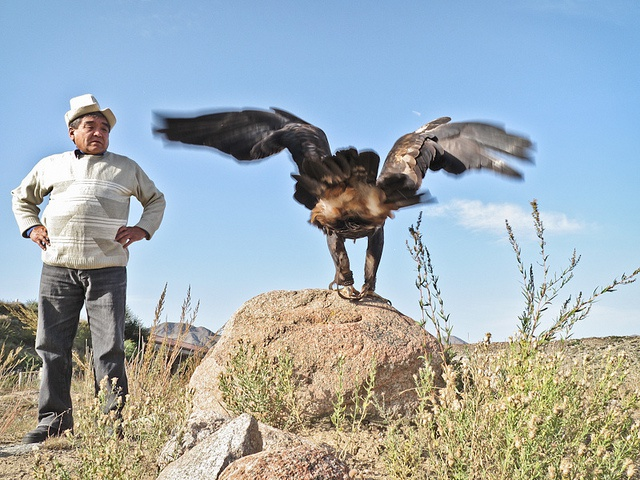Describe the objects in this image and their specific colors. I can see people in lightblue, darkgray, white, black, and gray tones and bird in lightblue, black, gray, and darkgray tones in this image. 